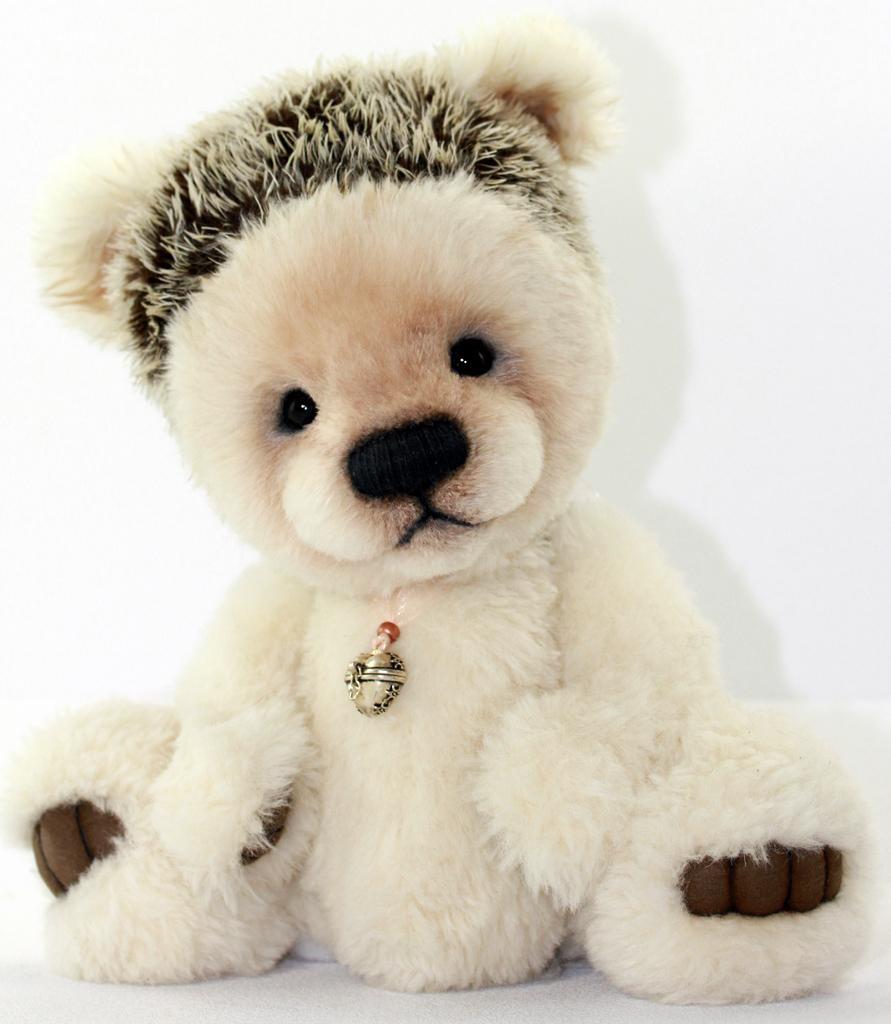Could you give a brief overview of what you see in this image? Background portion of the picture is white in color. In this picture we can see a teddy bear. We can see a locket. 